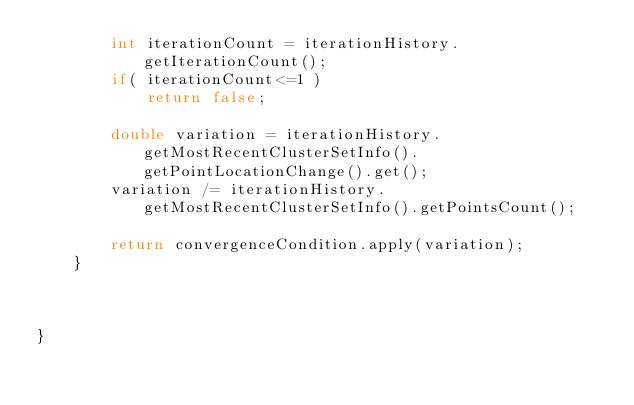Convert code to text. <code><loc_0><loc_0><loc_500><loc_500><_Java_>		int iterationCount = iterationHistory.getIterationCount();
		if( iterationCount<=1 )
			return false;
		
		double variation = iterationHistory.getMostRecentClusterSetInfo().getPointLocationChange().get();
		variation /= iterationHistory.getMostRecentClusterSetInfo().getPointsCount();
		
		return convergenceCondition.apply(variation);
	}

	

}
</code> 